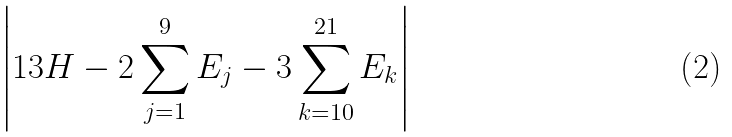Convert formula to latex. <formula><loc_0><loc_0><loc_500><loc_500>\left | 1 3 H - 2 \sum _ { j = 1 } ^ { 9 } E _ { j } - 3 \sum _ { k = 1 0 } ^ { 2 1 } E _ { k } \right |</formula> 